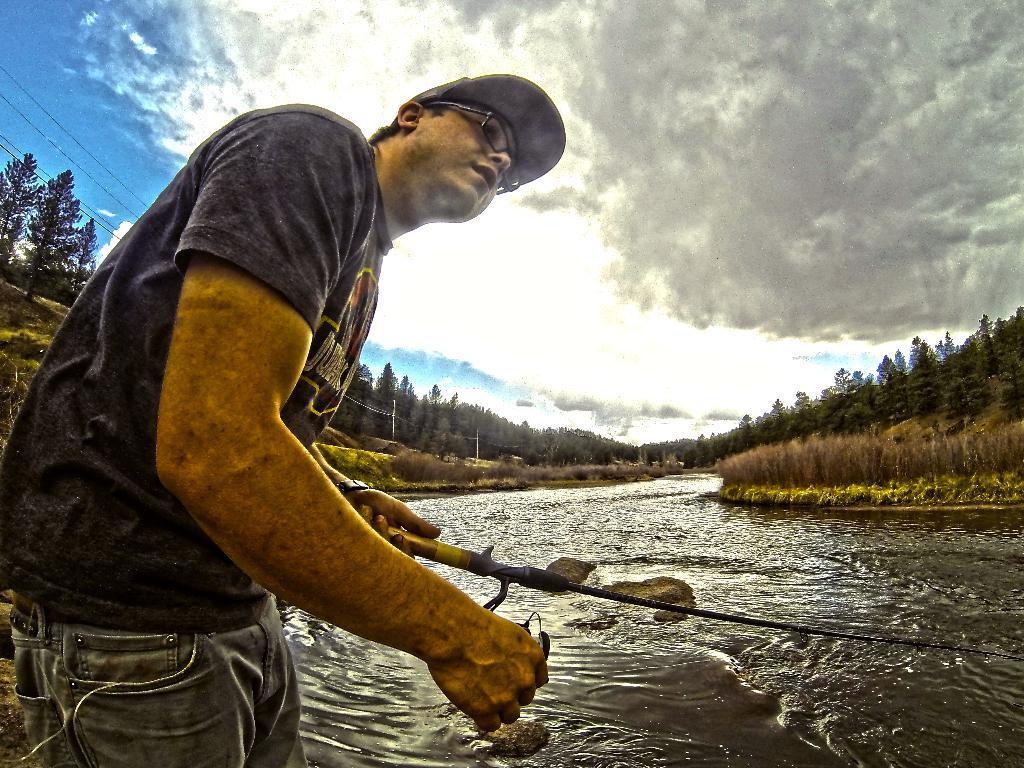Please provide a concise description of this image. In this picture we can see a man wearing black color t-shirt holding a fish stick in the hand. Behind we can see the beautiful view of the river with trees surrounded the river. Above we can see blue sky. 